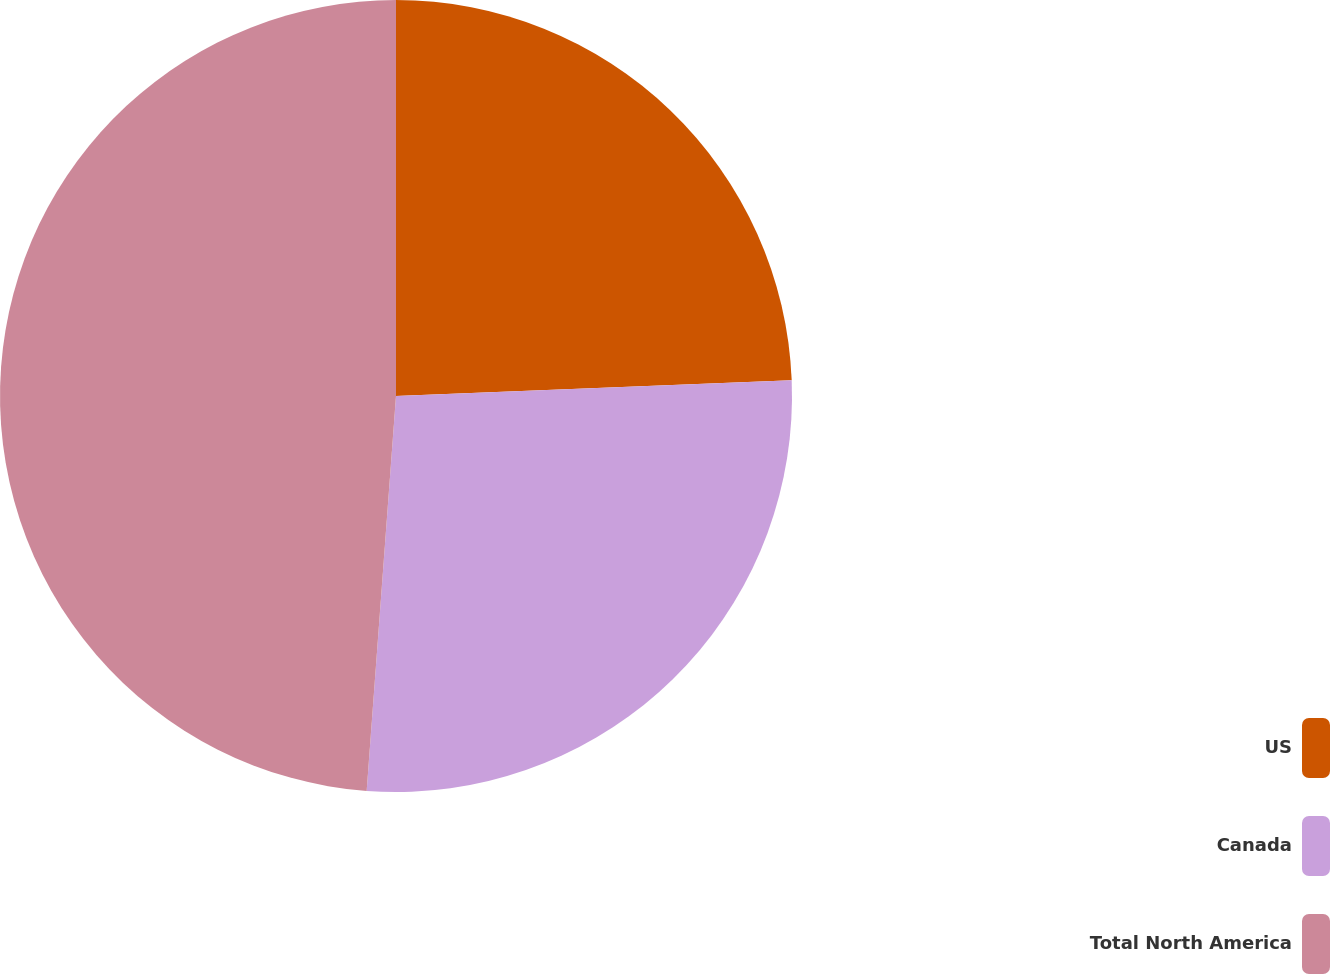Convert chart. <chart><loc_0><loc_0><loc_500><loc_500><pie_chart><fcel>US<fcel>Canada<fcel>Total North America<nl><fcel>24.37%<fcel>26.81%<fcel>48.82%<nl></chart> 